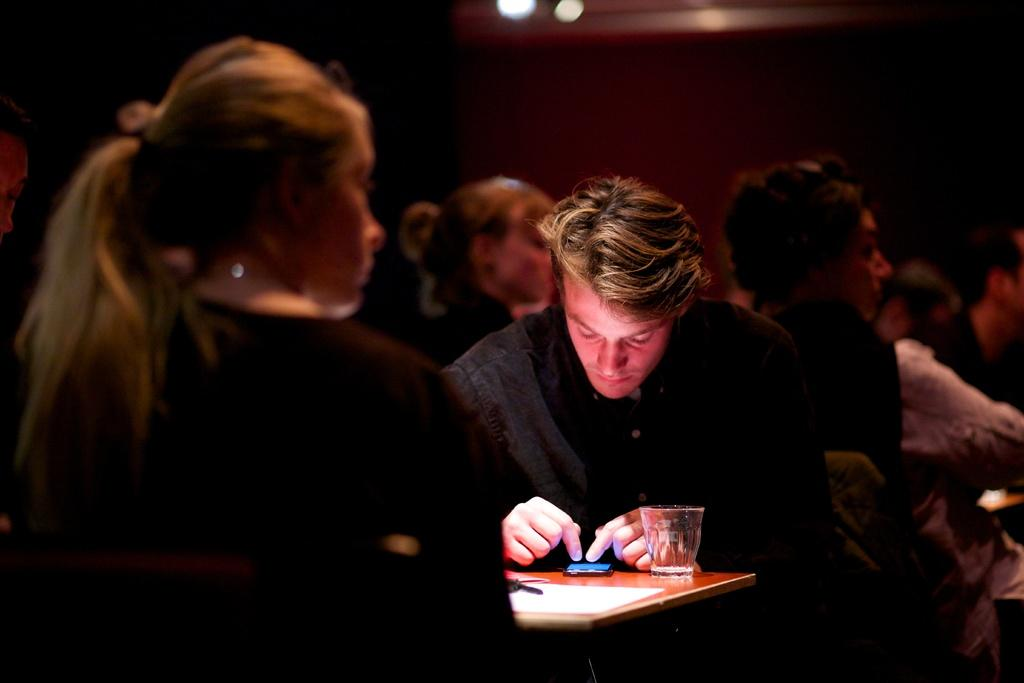What is the person in the image doing? There is a person sitting in the image, but the specific activity cannot be determined from the provided facts. What is located in front of the person? There is a mobile, a glass, and a paper in front of the person. What can be seen on the table in the image? There are objects on the table, but their specific nature cannot be determined from the provided facts. What is visible in the background of the image? There are people visible in the background, and the background color is dark. What is the purpose of the elbow in the image? There is no mention of an elbow in the image, so it cannot be determined what its purpose might be. 